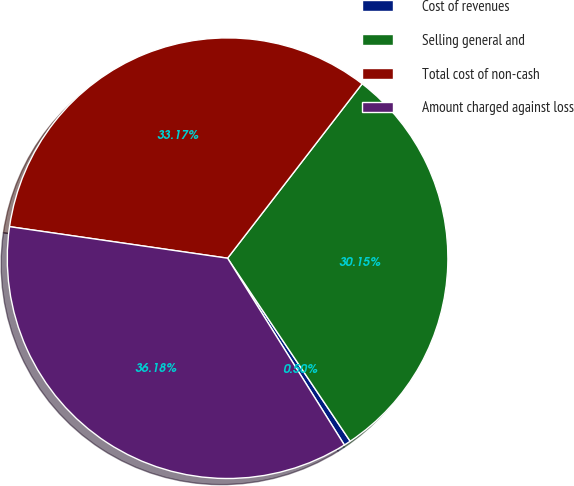Convert chart to OTSL. <chart><loc_0><loc_0><loc_500><loc_500><pie_chart><fcel>Cost of revenues<fcel>Selling general and<fcel>Total cost of non-cash<fcel>Amount charged against loss<nl><fcel>0.5%<fcel>30.15%<fcel>33.17%<fcel>36.18%<nl></chart> 